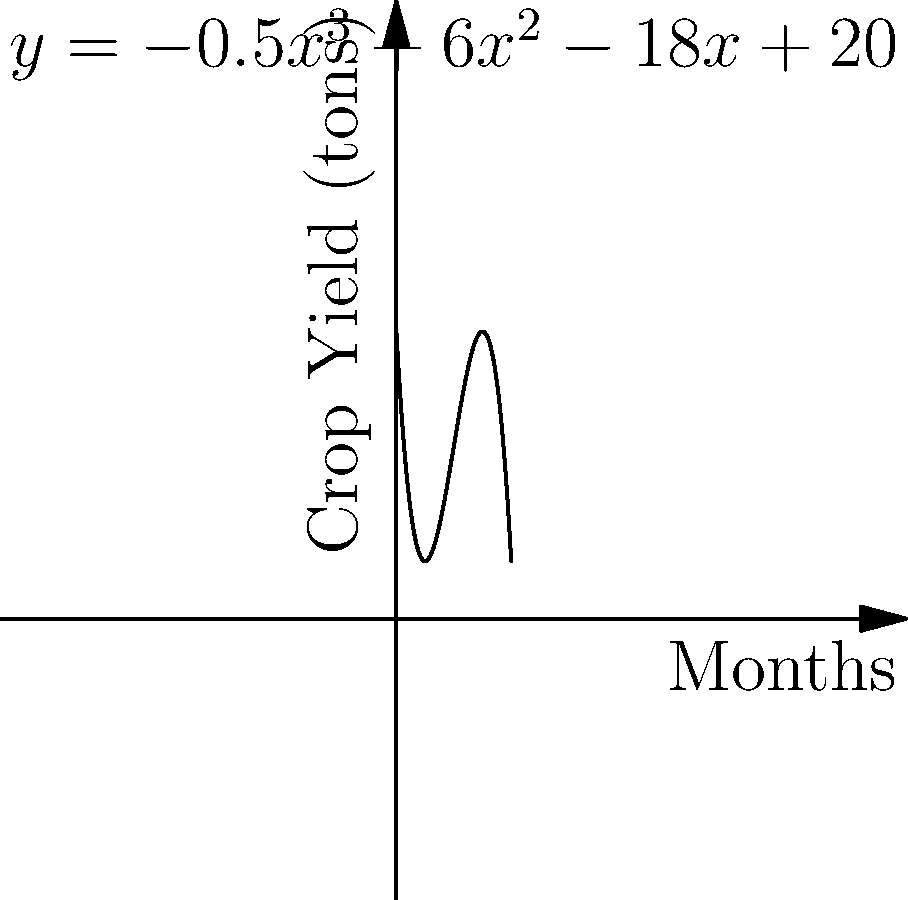The polynomial $y = -0.5x^3 + 6x^2 - 18x + 20$ represents the predicted crop yield (in tons) for a local farm supplying the hospital over the next 8 months. At which month will the crop yield be at its maximum, and what is the maximum yield? To find the maximum crop yield, we need to follow these steps:

1) First, we need to find the derivative of the polynomial:
   $f'(x) = -1.5x^2 + 12x - 18$

2) Set the derivative equal to zero to find critical points:
   $-1.5x^2 + 12x - 18 = 0$

3) Solve this quadratic equation:
   $-1.5(x^2 - 8x + 12) = 0$
   $-1.5(x - 6)(x - 2) = 0$
   $x = 6$ or $x = 2$

4) The second derivative is $f''(x) = -3x + 12$. 
   At $x = 2$, $f''(2) = 6 > 0$, so this is a local minimum.
   At $x = 6$, $f''(6) = -6 < 0$, so this is a local maximum.

5) Therefore, the maximum occurs at 6 months.

6) To find the maximum yield, plug $x = 6$ into the original equation:
   $y = -0.5(6)^3 + 6(6)^2 - 18(6) + 20$
   $y = -108 + 216 - 108 + 20 = 20$ tons

Thus, the maximum crop yield of 20 tons will occur at 6 months.
Answer: 6 months; 20 tons 